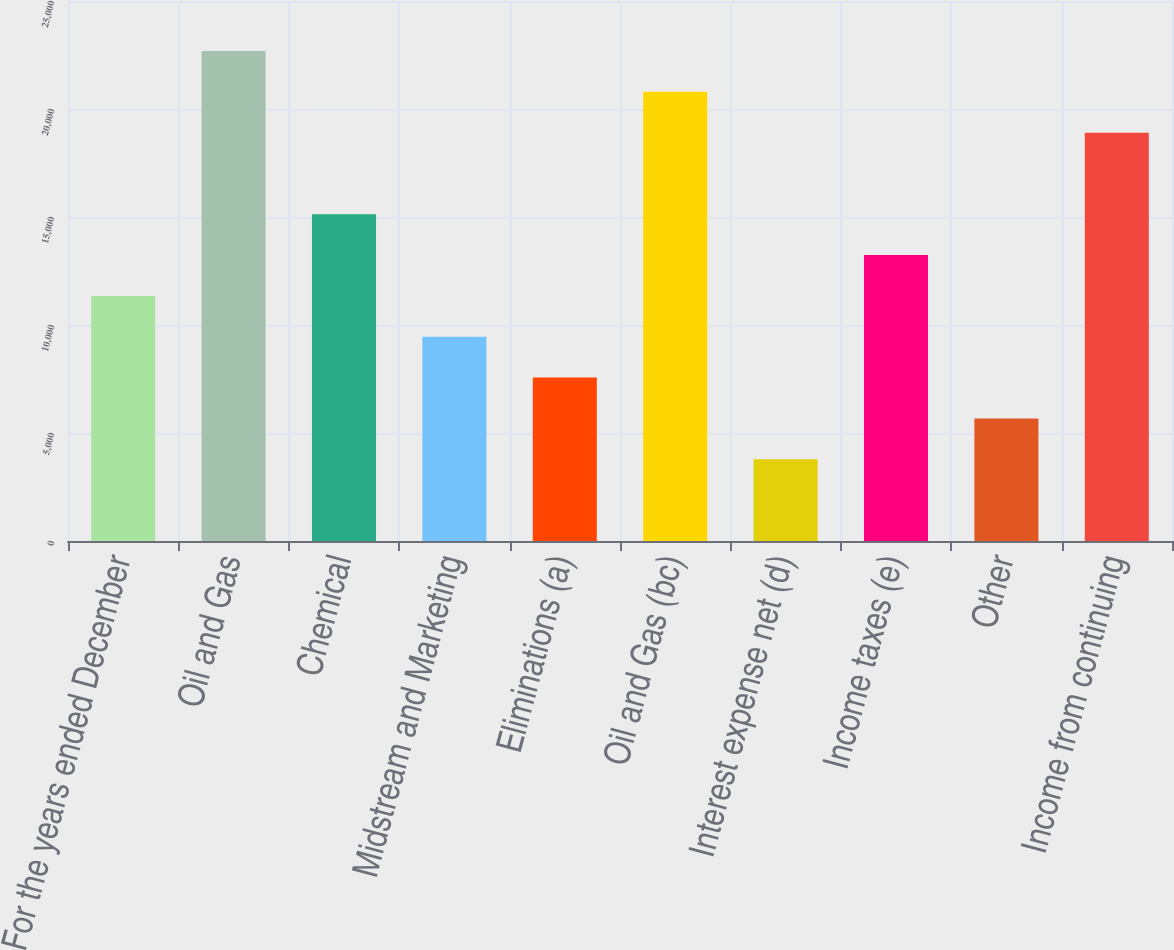Convert chart. <chart><loc_0><loc_0><loc_500><loc_500><bar_chart><fcel>For the years ended December<fcel>Oil and Gas<fcel>Chemical<fcel>Midstream and Marketing<fcel>Eliminations (a)<fcel>Oil and Gas (bc)<fcel>Interest expense net (d)<fcel>Income taxes (e)<fcel>Other<fcel>Income from continuing<nl><fcel>11345.9<fcel>22686<fcel>15125.9<fcel>9455.82<fcel>7565.79<fcel>20796<fcel>3785.73<fcel>13235.9<fcel>5675.76<fcel>18906<nl></chart> 